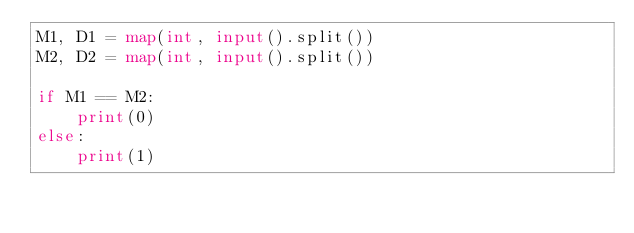Convert code to text. <code><loc_0><loc_0><loc_500><loc_500><_Python_>M1, D1 = map(int, input().split())
M2, D2 = map(int, input().split())

if M1 == M2:
    print(0)
else:
    print(1)
</code> 